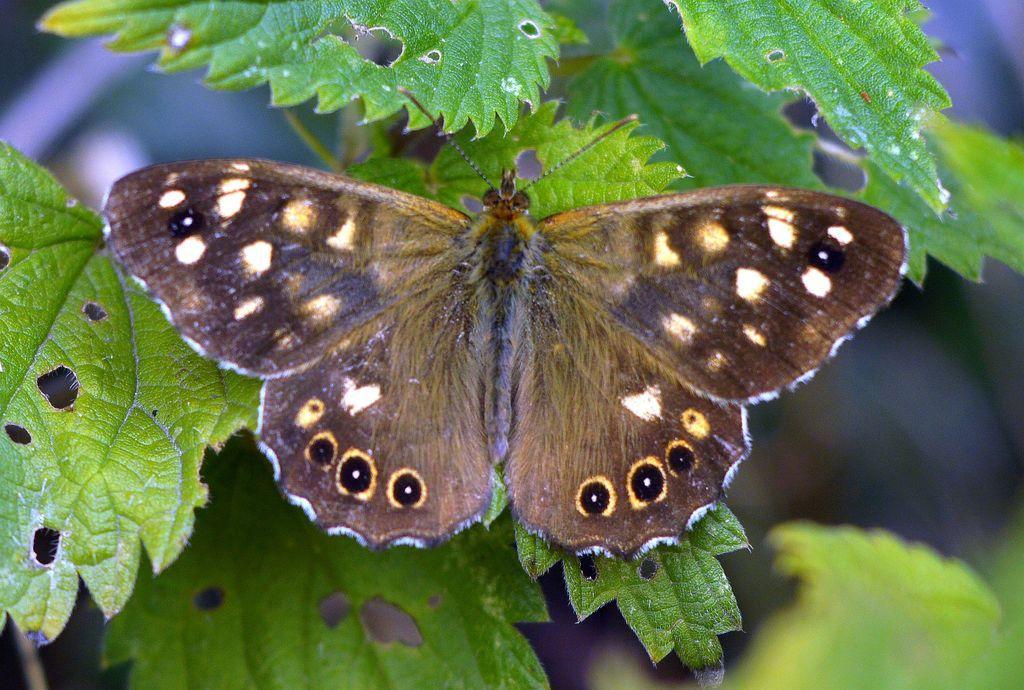Please provide a concise description of this image. In the center of the image, we can see a butterfly and in the background, there are leaves. 